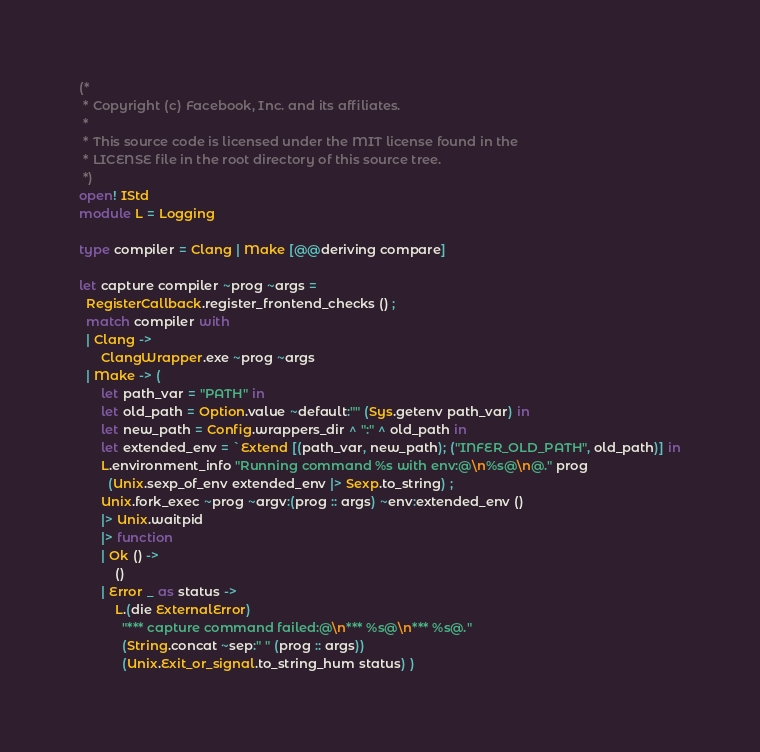<code> <loc_0><loc_0><loc_500><loc_500><_OCaml_>(*
 * Copyright (c) Facebook, Inc. and its affiliates.
 *
 * This source code is licensed under the MIT license found in the
 * LICENSE file in the root directory of this source tree.
 *)
open! IStd
module L = Logging

type compiler = Clang | Make [@@deriving compare]

let capture compiler ~prog ~args =
  RegisterCallback.register_frontend_checks () ;
  match compiler with
  | Clang ->
      ClangWrapper.exe ~prog ~args
  | Make -> (
      let path_var = "PATH" in
      let old_path = Option.value ~default:"" (Sys.getenv path_var) in
      let new_path = Config.wrappers_dir ^ ":" ^ old_path in
      let extended_env = `Extend [(path_var, new_path); ("INFER_OLD_PATH", old_path)] in
      L.environment_info "Running command %s with env:@\n%s@\n@." prog
        (Unix.sexp_of_env extended_env |> Sexp.to_string) ;
      Unix.fork_exec ~prog ~argv:(prog :: args) ~env:extended_env ()
      |> Unix.waitpid
      |> function
      | Ok () ->
          ()
      | Error _ as status ->
          L.(die ExternalError)
            "*** capture command failed:@\n*** %s@\n*** %s@."
            (String.concat ~sep:" " (prog :: args))
            (Unix.Exit_or_signal.to_string_hum status) )
</code> 